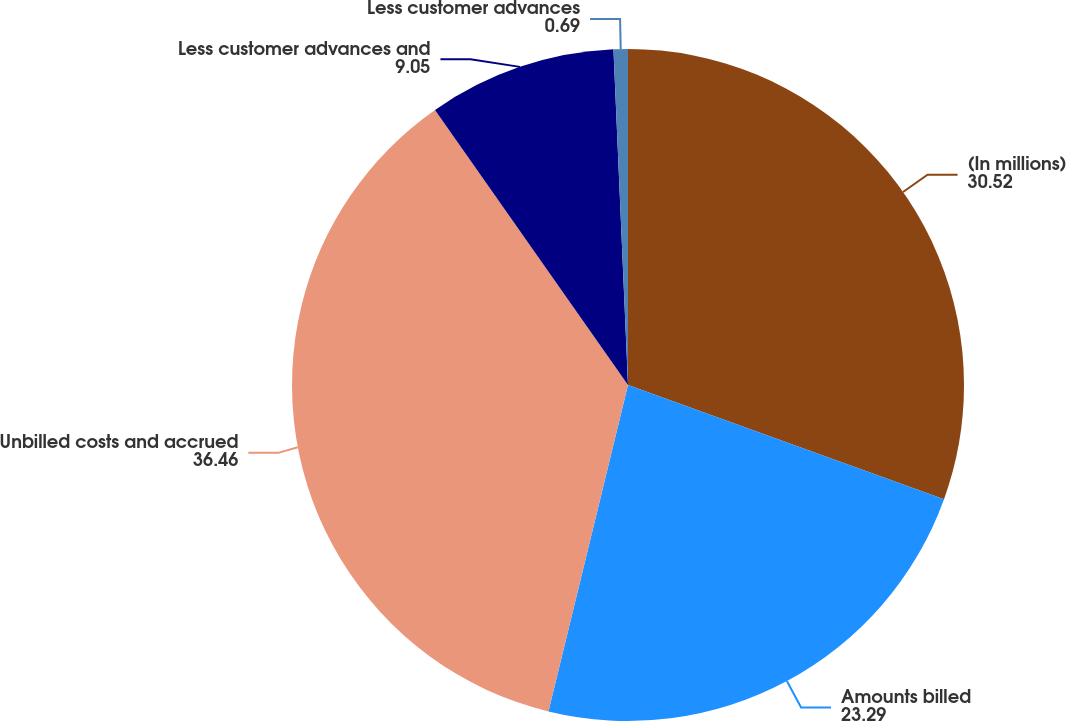Convert chart to OTSL. <chart><loc_0><loc_0><loc_500><loc_500><pie_chart><fcel>(In millions)<fcel>Amounts billed<fcel>Unbilled costs and accrued<fcel>Less customer advances and<fcel>Less customer advances<nl><fcel>30.52%<fcel>23.29%<fcel>36.46%<fcel>9.05%<fcel>0.69%<nl></chart> 